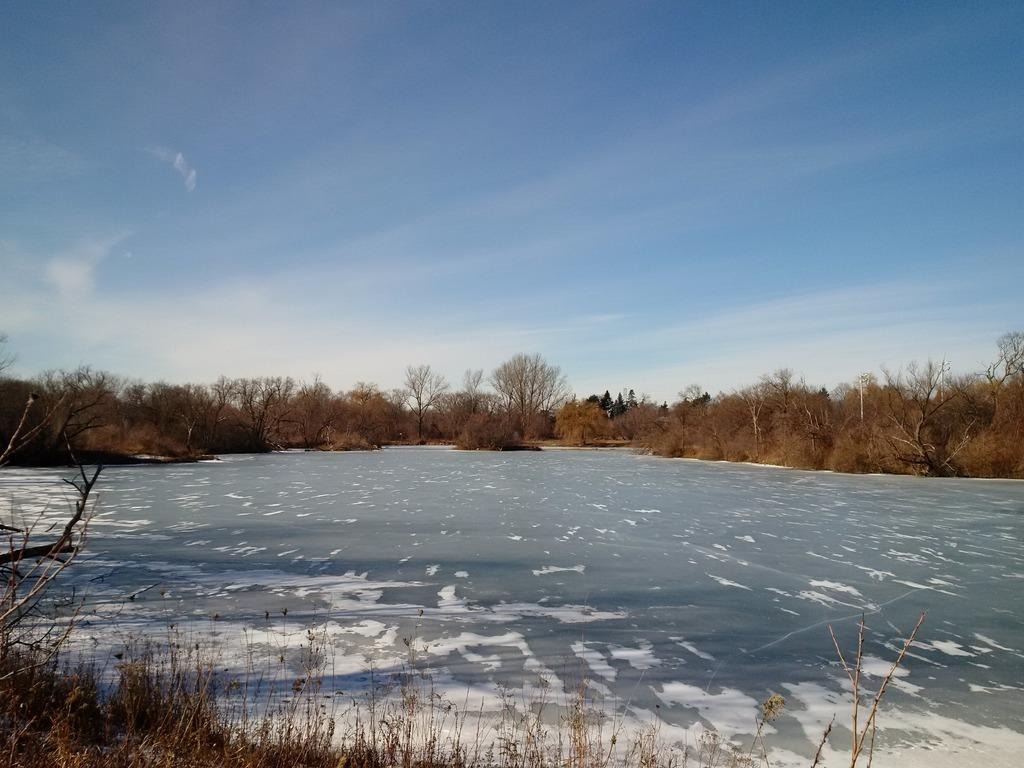What type of natural feature is at the bottom of the image? There is a river at the bottom of the image. What is located near the river? There are plants near the river. What can be seen in the background of the image? There are trees in the background of the image. What is visible at the top of the image? The sky is visible at the top of the image. What type of bomb can be seen exploding in the image? There is no bomb present in the image; it features a river, plants, trees, and the sky. What activity is taking place near the river in the image? The image does not depict any specific activity near the river; it simply shows the river, plants, trees, and the sky. 